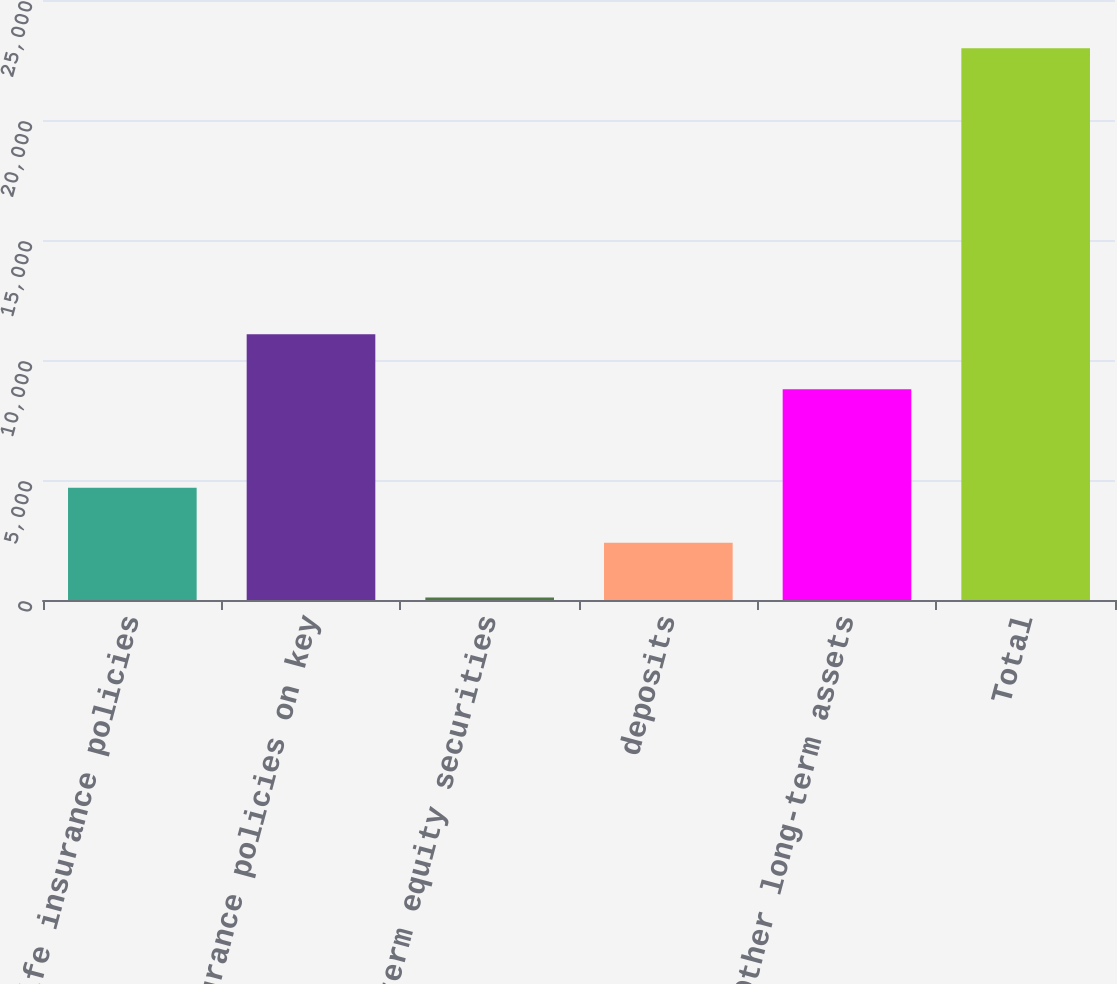Convert chart to OTSL. <chart><loc_0><loc_0><loc_500><loc_500><bar_chart><fcel>Life insurance policies<fcel>Life insurance policies on key<fcel>Long-term equity securities<fcel>deposits<fcel>Other long-term assets<fcel>Total<nl><fcel>4678.2<fcel>11068.1<fcel>100<fcel>2389.1<fcel>8779<fcel>22991<nl></chart> 